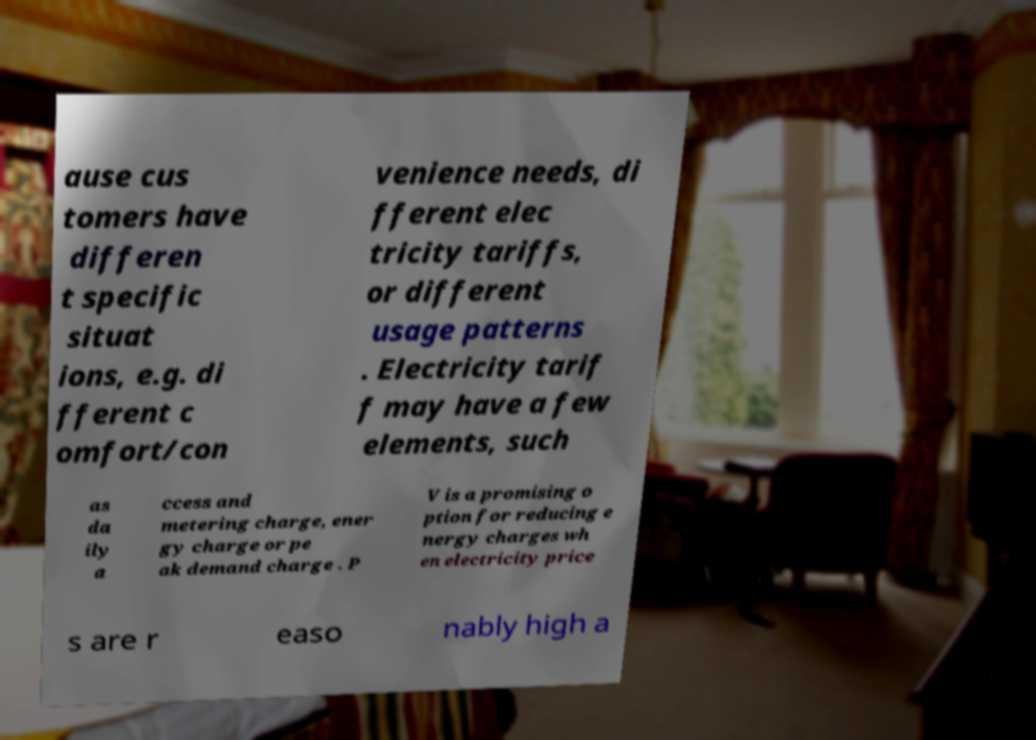Could you extract and type out the text from this image? ause cus tomers have differen t specific situat ions, e.g. di fferent c omfort/con venience needs, di fferent elec tricity tariffs, or different usage patterns . Electricity tarif f may have a few elements, such as da ily a ccess and metering charge, ener gy charge or pe ak demand charge . P V is a promising o ption for reducing e nergy charges wh en electricity price s are r easo nably high a 